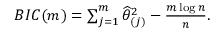Convert formula to latex. <formula><loc_0><loc_0><loc_500><loc_500>\begin{array} { r } { B I C ( m ) = \sum _ { j = 1 } ^ { m } \widehat { \theta } _ { ( j ) } ^ { 2 } - \frac { m \log n } { n } . } \end{array}</formula> 